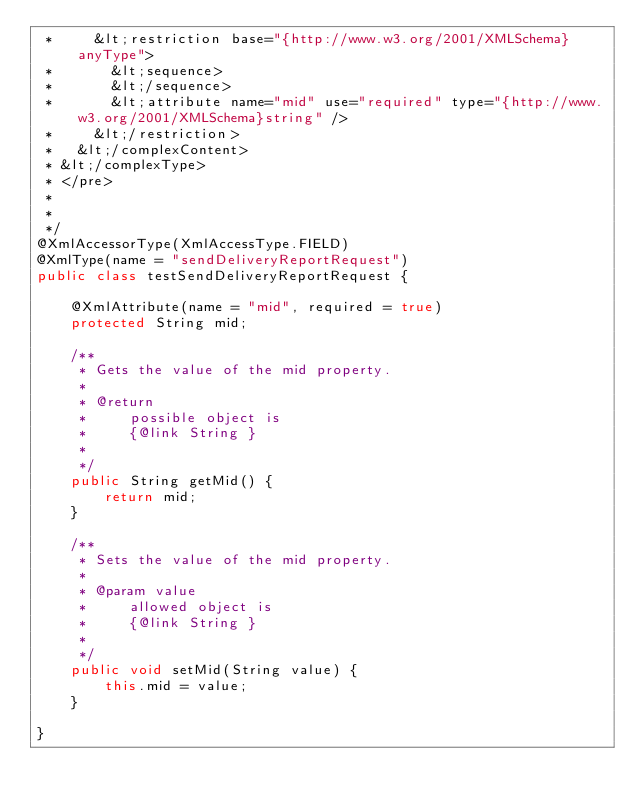Convert code to text. <code><loc_0><loc_0><loc_500><loc_500><_Java_> *     &lt;restriction base="{http://www.w3.org/2001/XMLSchema}anyType">
 *       &lt;sequence>
 *       &lt;/sequence>
 *       &lt;attribute name="mid" use="required" type="{http://www.w3.org/2001/XMLSchema}string" />
 *     &lt;/restriction>
 *   &lt;/complexContent>
 * &lt;/complexType>
 * </pre>
 * 
 * 
 */
@XmlAccessorType(XmlAccessType.FIELD)
@XmlType(name = "sendDeliveryReportRequest")
public class testSendDeliveryReportRequest {

    @XmlAttribute(name = "mid", required = true)
    protected String mid;

    /**
     * Gets the value of the mid property.
     * 
     * @return
     *     possible object is
     *     {@link String }
     *     
     */
    public String getMid() {
        return mid;
    }

    /**
     * Sets the value of the mid property.
     * 
     * @param value
     *     allowed object is
     *     {@link String }
     *     
     */
    public void setMid(String value) {
        this.mid = value;
    }

}
</code> 